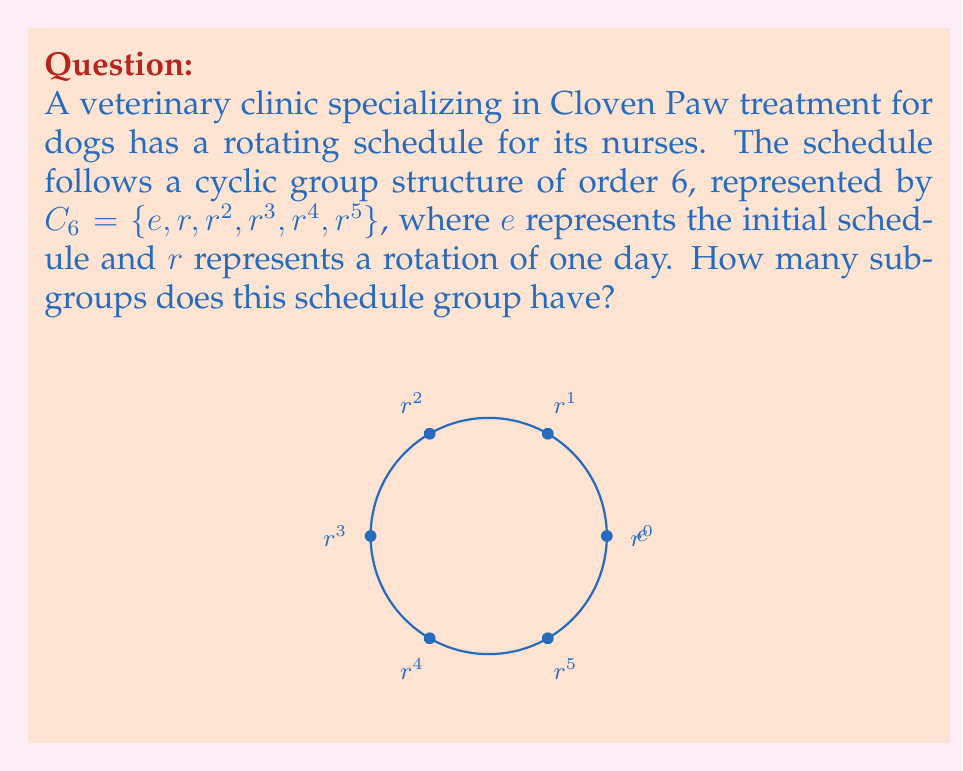What is the answer to this math problem? To find the number of subgroups in the cyclic group $C_6$, we need to follow these steps:

1) First, recall that the subgroups of a cyclic group correspond to the divisors of the group's order. The order of $C_6$ is 6.

2) Find the divisors of 6:
   The divisors of 6 are 1, 2, 3, and 6.

3) For each divisor $d$, there is a unique subgroup of order $d$:

   - For $d=1$: $\{e\}$ (the trivial subgroup)
   - For $d=2$: $\{e, r^3\}$
   - For $d=3$: $\{e, r^2, r^4\}$
   - For $d=6$: $\{e, r, r^2, r^3, r^4, r^5\}$ (the entire group)

4) Count the number of subgroups:
   There is one subgroup for each divisor of 6.

Therefore, the number of subgroups is equal to the number of divisors of 6, which is 4.
Answer: 4 